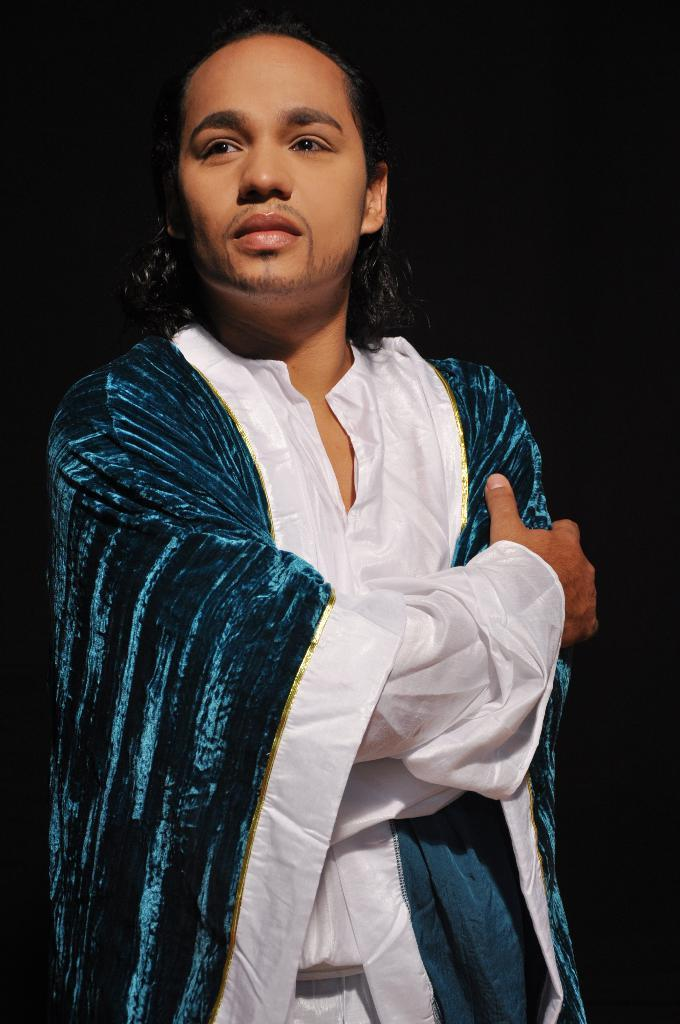What is the main subject of the image? The main subject of the image is a person standing. What can be observed about the background of the image? The background of the image is dark. What type of recess can be seen in the image? There is no recess present in the image. What loss is being experienced by the person in the image? There is no indication of any loss being experienced by the person in the image. 